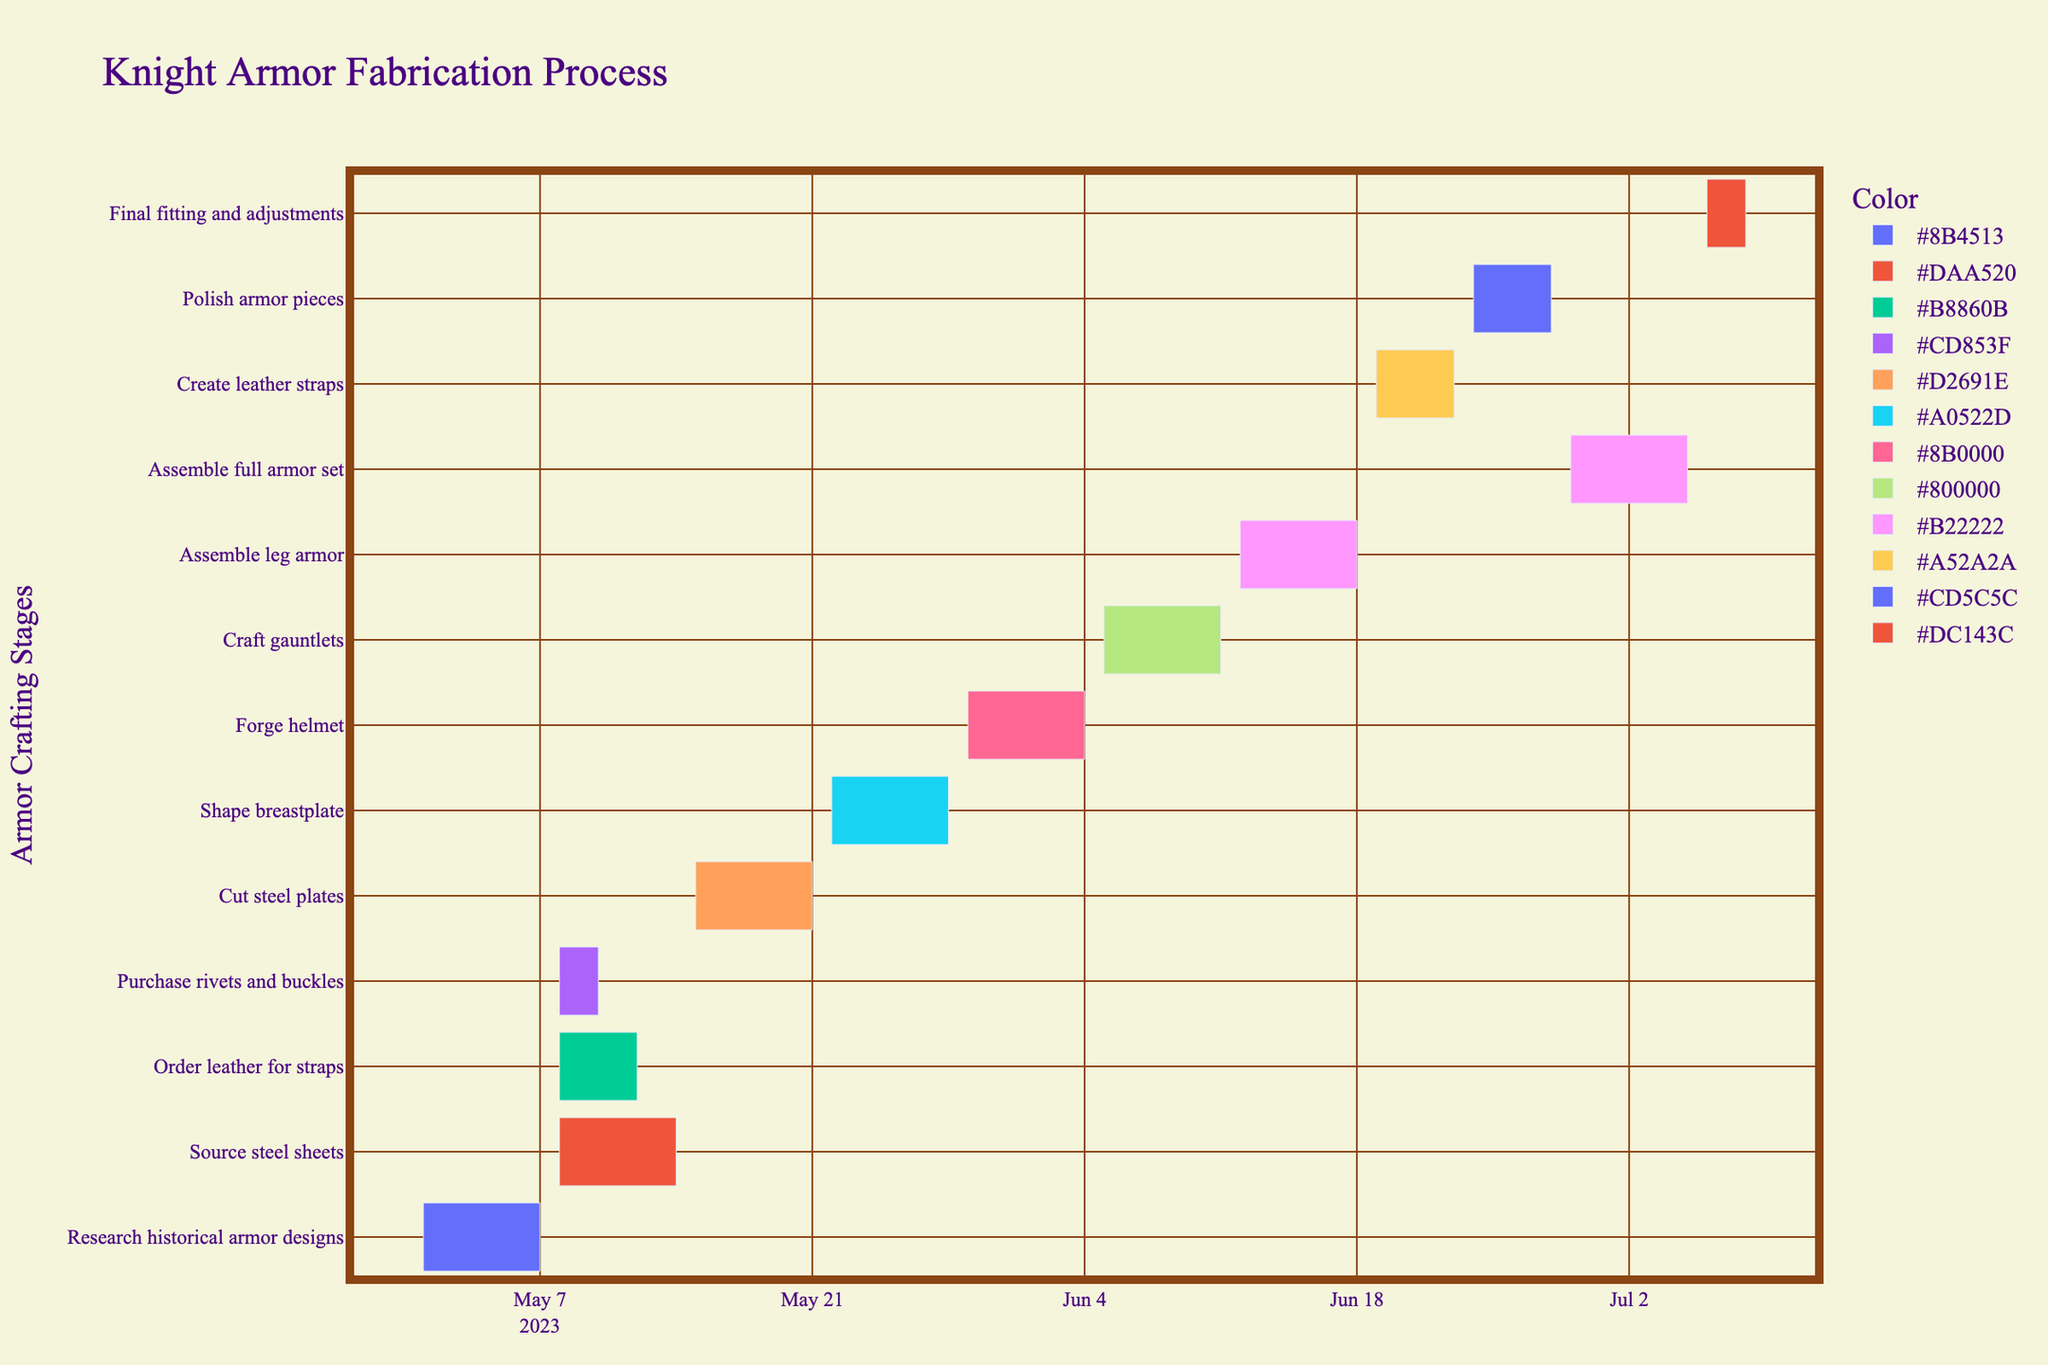What is the title of the chart? The title of the chart is "Knight Armor Fabrication Process." This is stated at the top of the chart.
Answer: Knight Armor Fabrication Process What material procurement tasks begin on the same day? The tasks that begin on the same day are "Source steel sheets," "Order leather for straps," and "Purchase rivets and buckles." These all start on May 8, 2023.
Answer: Source steel sheets, Order leather for straps, Purchase rivets and buckles Which task has the shortest duration? The task with the shortest duration is "Purchase rivets and buckles," which lasts for 3 days from May 8 to May 10, 2023.
Answer: Purchase rivets and buckles How many days are there between the start of "Forge helmet" and the end of "Assemble full armor set"? "Forge helmet" starts on May 29, 2023, and "Assemble full armor set" ends on July 5, 2023. The time difference between these two dates is 37 days.
Answer: 37 days Comparing the "Shape breastplate" and "Craft gauntlets" tasks, which one ends later? "Craft gauntlets" ends on June 11, 2023, while "Shape breastplate" ends on May 28, 2023. Thus, "Craft gauntlets" ends later.
Answer: Craft gauntlets Find the total duration of all tasks related to assembling the armor. The tasks to consider are "Assemble leg armor," "Assemble full armor set," and "Final fitting and adjustments," which last 7, 7, and 3 days respectively. The total duration is 7+7+3 = 17 days.
Answer: 17 days Which tasks overlap with "Create leather straps"? "Create leather straps" runs from June 19 to June 23, 2023. The overlapping tasks are "Assemble leg armor" (June 12 to June 18) and "Polish armor pieces" (June 24 to June 28). There are no overlaps within the exact same date range.
Answer: None How many days does the "Cut steel plates" task span? The task "Cut steel plates" spans from May 15 to May 21, 2023, which is 7 days.
Answer: 7 days Which task directly follows "Shape breastplate"? The task that directly follows "Shape breastplate" is "Forge helmet," starting on May 29, 2023, right after "Shape breastplate" ends on May 28, 2023.
Answer: Forge helmet What is the color associated with the task "Polish armor pieces"? The color associated with "Polish armor pieces" is a shade of red. Different tasks are color-coded, and in this chart, "Polish" tasks use a shade of red.
Answer: Red shade 